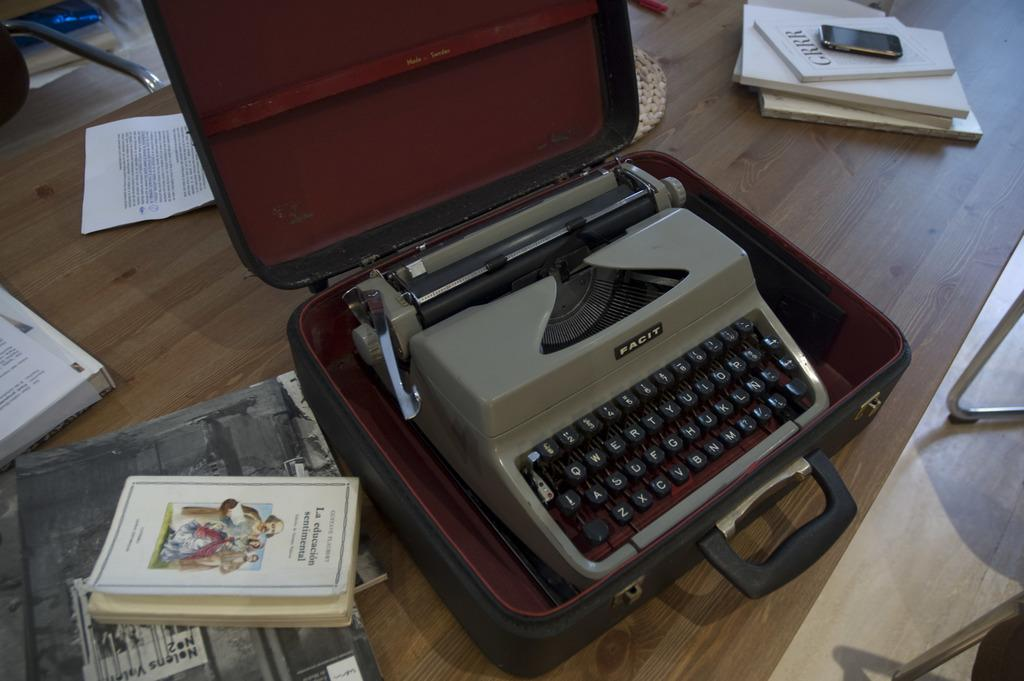What type of furniture is in the image? There is a wooden desk in the image. What items can be seen on the desk? There are books, a mobile, a typewriter, and a briefcase on the desk. Are there any other objects on the desk? Yes, there are other objects on the desk. What is visible on the right side of the image? The legs of a chair are visible on the right side of the image. What might the legs belong to? The legs are likely to belong to a chair. What type of print can be seen on the deer's fur in the image? There is no deer present in the image, so it is not possible to determine the type of print on its fur. 